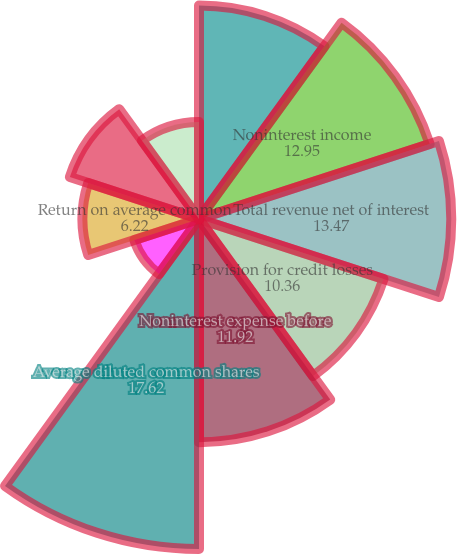<chart> <loc_0><loc_0><loc_500><loc_500><pie_chart><fcel>Net interest income<fcel>Noninterest income<fcel>Total revenue net of interest<fcel>Provision for credit losses<fcel>Noninterest expense before<fcel>Average diluted common shares<fcel>Return on average assets<fcel>Return on average common<fcel>Return on average tangible<fcel>Total ending equity to total<nl><fcel>11.4%<fcel>12.95%<fcel>13.47%<fcel>10.36%<fcel>11.92%<fcel>17.62%<fcel>3.63%<fcel>6.22%<fcel>7.25%<fcel>5.18%<nl></chart> 